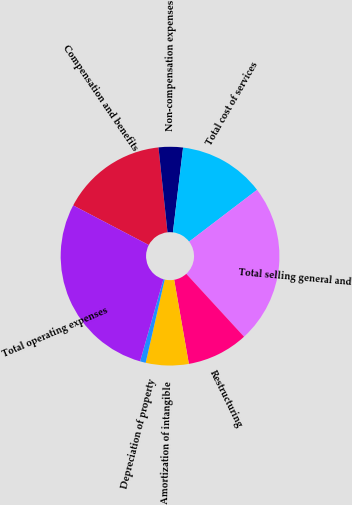Convert chart to OTSL. <chart><loc_0><loc_0><loc_500><loc_500><pie_chart><fcel>Compensation and benefits<fcel>Non-compensation expenses<fcel>Total cost of services<fcel>Total selling general and<fcel>Restructuring<fcel>Amortization of intangible<fcel>Depreciation of property<fcel>Total operating expenses<nl><fcel>15.63%<fcel>3.59%<fcel>12.73%<fcel>23.54%<fcel>9.07%<fcel>6.33%<fcel>0.84%<fcel>28.26%<nl></chart> 